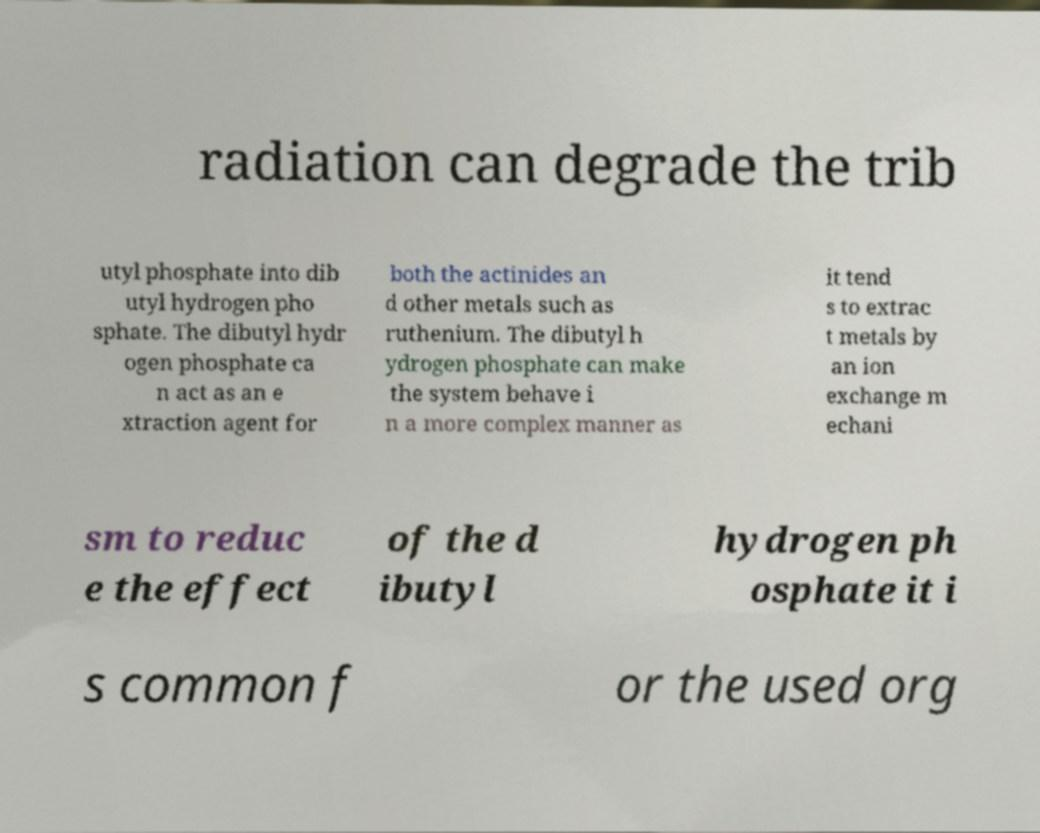What messages or text are displayed in this image? I need them in a readable, typed format. radiation can degrade the trib utyl phosphate into dib utyl hydrogen pho sphate. The dibutyl hydr ogen phosphate ca n act as an e xtraction agent for both the actinides an d other metals such as ruthenium. The dibutyl h ydrogen phosphate can make the system behave i n a more complex manner as it tend s to extrac t metals by an ion exchange m echani sm to reduc e the effect of the d ibutyl hydrogen ph osphate it i s common f or the used org 